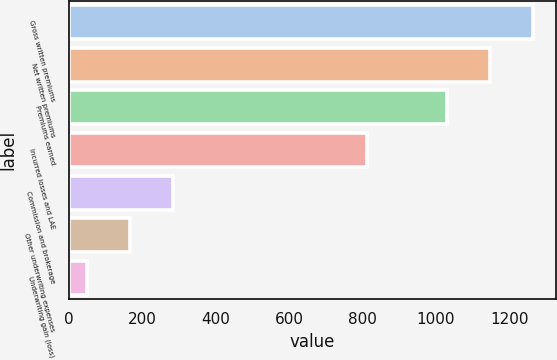<chart> <loc_0><loc_0><loc_500><loc_500><bar_chart><fcel>Gross written premiums<fcel>Net written premiums<fcel>Premiums earned<fcel>Incurred losses and LAE<fcel>Commission and brokerage<fcel>Other underwriting expenses<fcel>Underwriting gain (loss)<nl><fcel>1264.2<fcel>1147.25<fcel>1030.3<fcel>811.4<fcel>282.8<fcel>165.85<fcel>48.9<nl></chart> 